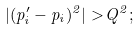<formula> <loc_0><loc_0><loc_500><loc_500>| ( p ^ { \prime } _ { i } - p _ { i } ) ^ { 2 } | > Q ^ { 2 } ;</formula> 